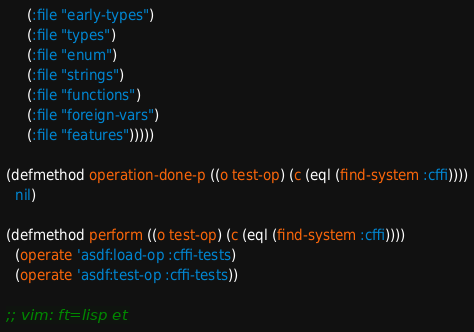<code> <loc_0><loc_0><loc_500><loc_500><_Lisp_>     (:file "early-types")
     (:file "types")
     (:file "enum")
     (:file "strings")
     (:file "functions")
     (:file "foreign-vars")
     (:file "features")))))

(defmethod operation-done-p ((o test-op) (c (eql (find-system :cffi))))
  nil)

(defmethod perform ((o test-op) (c (eql (find-system :cffi))))
  (operate 'asdf:load-op :cffi-tests)
  (operate 'asdf:test-op :cffi-tests))

;; vim: ft=lisp et
</code> 